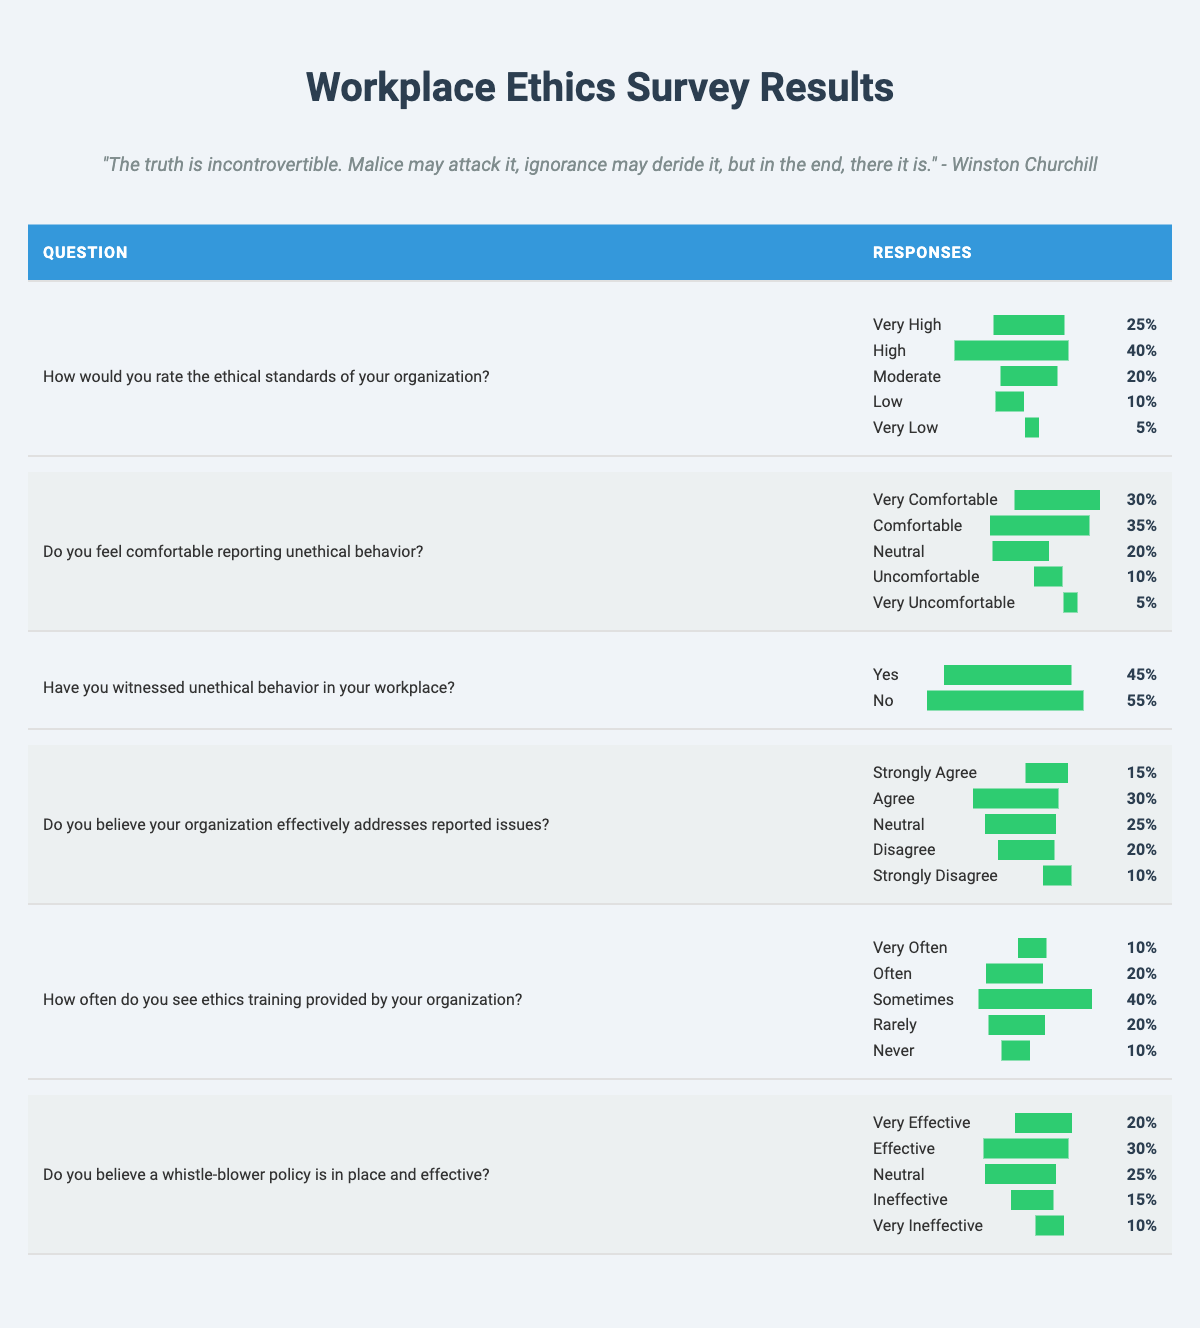What percentage of respondents rated the ethical standards of their organization as "Very High"? From the table, under the question regarding the ethical standards of the organization, the response "Very High" shows a percentage of 25%.
Answer: 25% What is the total percentage of respondents who feel "Comfortable" or "Very Comfortable" reporting unethical behavior? To find this, we add the percentages for both responses: Comfortable (35%) + Very Comfortable (30%) = 65%.
Answer: 65% Is the majority of respondents in favor of the effectiveness of the whistle-blower policy? The responses for "Effective" (30%) and "Very Effective" (20%) add up to 50%, which is not a majority since it requires over 50%.
Answer: No What percentage of respondents saw ethics training provided "Rarely" or "Never"? We combine the "Rarely" (20%) and "Never" (10%) responses: 20% + 10% = 30%.
Answer: 30% Which response had the highest percentage under the question about whether the organization effectively addresses reported issues? The response "Agree" has the highest percentage at 30%, compared to others.
Answer: Agree How many respondents witnessed unethical behavior in their workplace compared to those who did not? For "Yes" the percentage is 45% and for "No" it is 55%. Since 55% is greater than 45%, more people did not witness unethical behavior than those who did.
Answer: No What is the average percentage of respondents who rated their organization's ethical standards as "Moderate" or lower? Calculating this involves adding the percentages of "Moderate" (20%), "Low" (10%), and "Very Low" (5%): 20% + 10% + 5% = 35%. This is then divided by 3 (the number of categories): 35%/3 = approximately 11.67%.
Answer: Approximately 11.67% Who feels "Uncomfortable" reporting unethical behavior, and how significant is this group compared to those who feel "Very Comfortable"? The "Uncomfortable" percentage is 10%, while "Very Comfortable" is 30%. This indicates that those "Uncomfortable" make up a smaller proportion compared to the "Very Comfortable".
Answer: Smaller proportion What percentage of respondents are neutral about the organization effectively addressing reported issues? The "Neutral" response under that question accounts for 25%.
Answer: 25% 